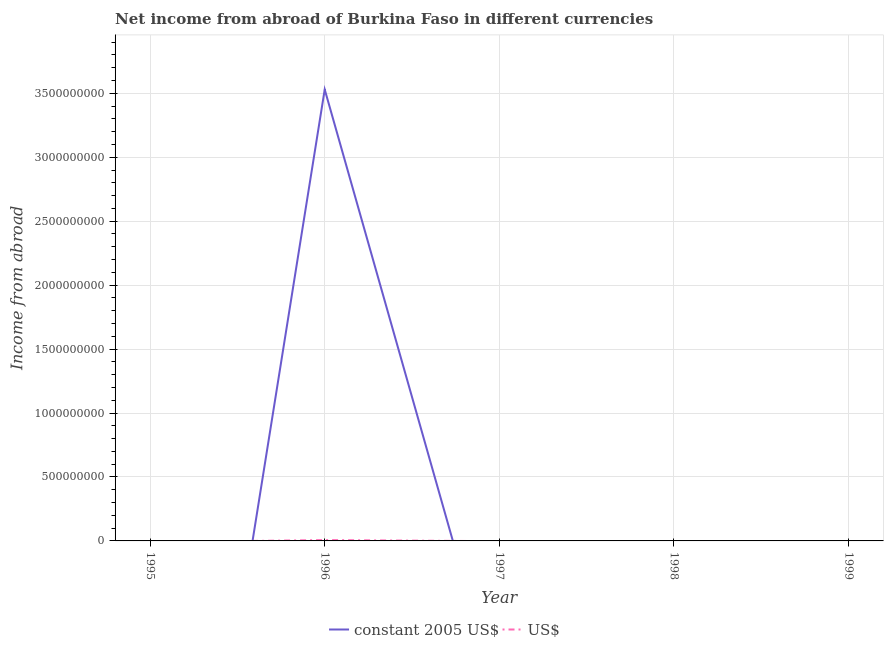How many different coloured lines are there?
Keep it short and to the point. 2. Does the line corresponding to income from abroad in constant 2005 us$ intersect with the line corresponding to income from abroad in us$?
Keep it short and to the point. Yes. Across all years, what is the maximum income from abroad in constant 2005 us$?
Ensure brevity in your answer.  3.53e+09. Across all years, what is the minimum income from abroad in us$?
Your response must be concise. 0. In which year was the income from abroad in constant 2005 us$ maximum?
Provide a succinct answer. 1996. What is the total income from abroad in constant 2005 us$ in the graph?
Make the answer very short. 3.53e+09. What is the difference between the income from abroad in us$ in 1996 and the income from abroad in constant 2005 us$ in 1999?
Make the answer very short. 6.90e+06. What is the average income from abroad in us$ per year?
Offer a very short reply. 1.38e+06. In the year 1996, what is the difference between the income from abroad in us$ and income from abroad in constant 2005 us$?
Your response must be concise. -3.52e+09. In how many years, is the income from abroad in us$ greater than 1200000000 units?
Make the answer very short. 0. What is the difference between the highest and the lowest income from abroad in constant 2005 us$?
Offer a terse response. 3.53e+09. Is the income from abroad in constant 2005 us$ strictly greater than the income from abroad in us$ over the years?
Make the answer very short. No. How many lines are there?
Keep it short and to the point. 2. How many years are there in the graph?
Your answer should be very brief. 5. Are the values on the major ticks of Y-axis written in scientific E-notation?
Offer a very short reply. No. Does the graph contain grids?
Give a very brief answer. Yes. How are the legend labels stacked?
Provide a succinct answer. Horizontal. What is the title of the graph?
Keep it short and to the point. Net income from abroad of Burkina Faso in different currencies. Does "Gasoline" appear as one of the legend labels in the graph?
Ensure brevity in your answer.  No. What is the label or title of the X-axis?
Provide a short and direct response. Year. What is the label or title of the Y-axis?
Provide a succinct answer. Income from abroad. What is the Income from abroad of constant 2005 US$ in 1996?
Offer a terse response. 3.53e+09. What is the Income from abroad in US$ in 1996?
Offer a terse response. 6.90e+06. What is the Income from abroad in constant 2005 US$ in 1997?
Offer a terse response. 0. What is the Income from abroad in US$ in 1997?
Your answer should be compact. 0. What is the Income from abroad in constant 2005 US$ in 1998?
Your answer should be compact. 0. What is the Income from abroad of US$ in 1998?
Make the answer very short. 0. What is the Income from abroad of constant 2005 US$ in 1999?
Offer a terse response. 0. Across all years, what is the maximum Income from abroad of constant 2005 US$?
Provide a short and direct response. 3.53e+09. Across all years, what is the maximum Income from abroad in US$?
Provide a succinct answer. 6.90e+06. Across all years, what is the minimum Income from abroad of constant 2005 US$?
Provide a succinct answer. 0. Across all years, what is the minimum Income from abroad in US$?
Make the answer very short. 0. What is the total Income from abroad of constant 2005 US$ in the graph?
Provide a succinct answer. 3.53e+09. What is the total Income from abroad in US$ in the graph?
Ensure brevity in your answer.  6.90e+06. What is the average Income from abroad of constant 2005 US$ per year?
Provide a succinct answer. 7.06e+08. What is the average Income from abroad of US$ per year?
Give a very brief answer. 1.38e+06. In the year 1996, what is the difference between the Income from abroad in constant 2005 US$ and Income from abroad in US$?
Offer a terse response. 3.52e+09. What is the difference between the highest and the lowest Income from abroad of constant 2005 US$?
Your response must be concise. 3.53e+09. What is the difference between the highest and the lowest Income from abroad in US$?
Give a very brief answer. 6.90e+06. 